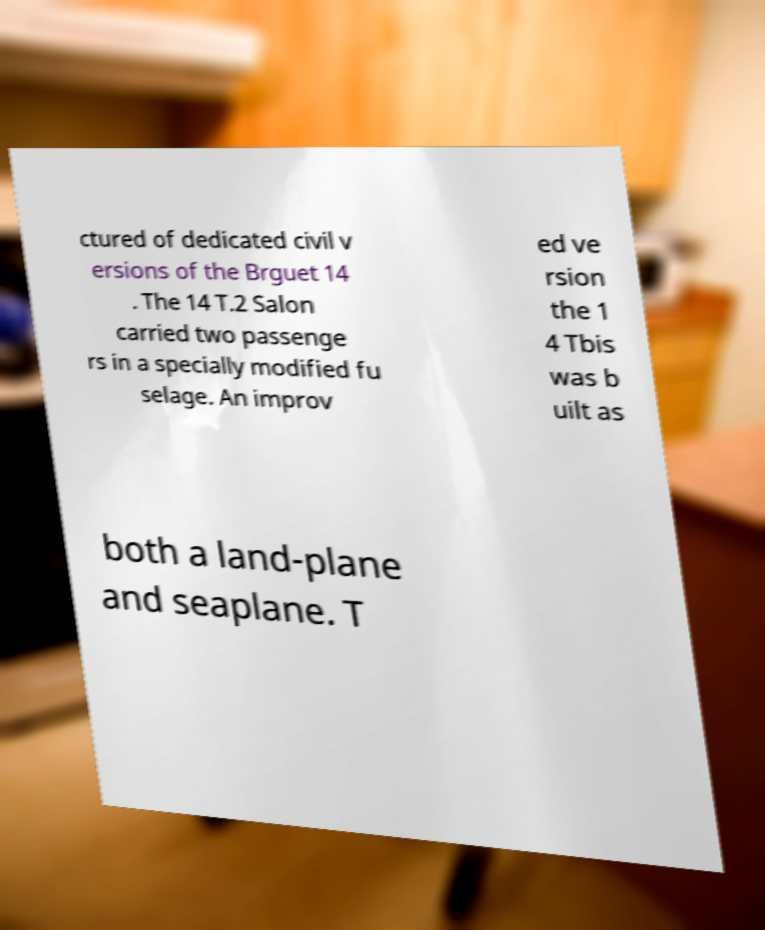For documentation purposes, I need the text within this image transcribed. Could you provide that? ctured of dedicated civil v ersions of the Brguet 14 . The 14 T.2 Salon carried two passenge rs in a specially modified fu selage. An improv ed ve rsion the 1 4 Tbis was b uilt as both a land-plane and seaplane. T 